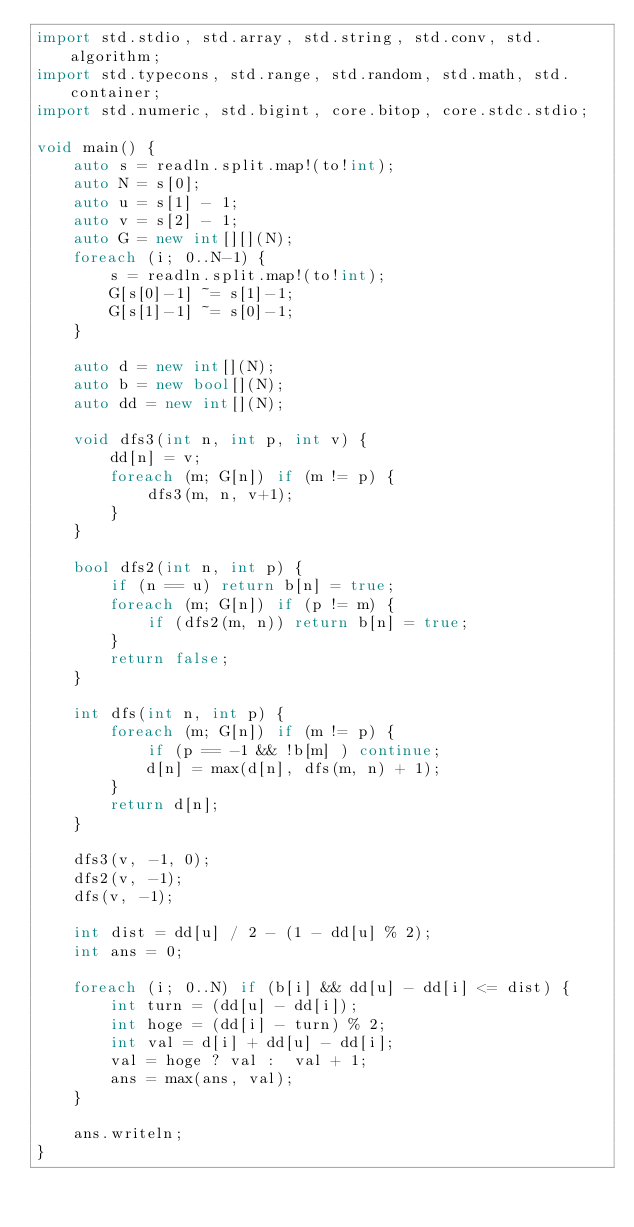Convert code to text. <code><loc_0><loc_0><loc_500><loc_500><_D_>import std.stdio, std.array, std.string, std.conv, std.algorithm;
import std.typecons, std.range, std.random, std.math, std.container;
import std.numeric, std.bigint, core.bitop, core.stdc.stdio;

void main() {
    auto s = readln.split.map!(to!int);
    auto N = s[0];
    auto u = s[1] - 1;
    auto v = s[2] - 1;
    auto G = new int[][](N);
    foreach (i; 0..N-1) {
        s = readln.split.map!(to!int);
        G[s[0]-1] ~= s[1]-1;
        G[s[1]-1] ~= s[0]-1;
    }

    auto d = new int[](N);
    auto b = new bool[](N);
    auto dd = new int[](N);

    void dfs3(int n, int p, int v) {
        dd[n] = v;
        foreach (m; G[n]) if (m != p) {
            dfs3(m, n, v+1);
        }
    }

    bool dfs2(int n, int p) {
        if (n == u) return b[n] = true;
        foreach (m; G[n]) if (p != m) {
            if (dfs2(m, n)) return b[n] = true;
        }
        return false;
    }

    int dfs(int n, int p) {
        foreach (m; G[n]) if (m != p) {
            if (p == -1 && !b[m] ) continue;
            d[n] = max(d[n], dfs(m, n) + 1);
        }
        return d[n];
    }

    dfs3(v, -1, 0);
    dfs2(v, -1);
    dfs(v, -1);

    int dist = dd[u] / 2 - (1 - dd[u] % 2);
    int ans = 0;

    foreach (i; 0..N) if (b[i] && dd[u] - dd[i] <= dist) {
        int turn = (dd[u] - dd[i]);
        int hoge = (dd[i] - turn) % 2;
        int val = d[i] + dd[u] - dd[i];
        val = hoge ? val :  val + 1;
        ans = max(ans, val);
    }

    ans.writeln;
}</code> 